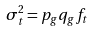<formula> <loc_0><loc_0><loc_500><loc_500>\sigma _ { t } ^ { 2 } = p _ { g } q _ { g } f _ { t }</formula> 